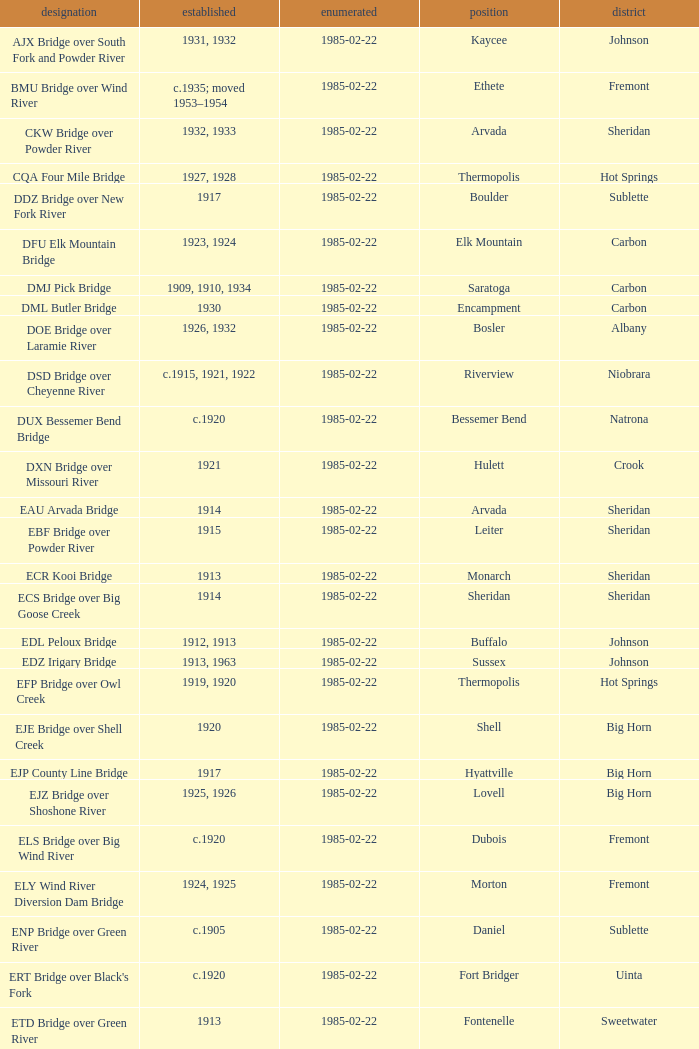Which bridge constructed in 1915 is located in sheridan county? EBF Bridge over Powder River. 